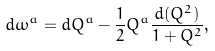<formula> <loc_0><loc_0><loc_500><loc_500>d \omega ^ { a } = d Q ^ { a } - \frac { 1 } { 2 } Q ^ { a } \frac { d ( Q ^ { 2 } ) } { 1 + Q ^ { 2 } } ,</formula> 